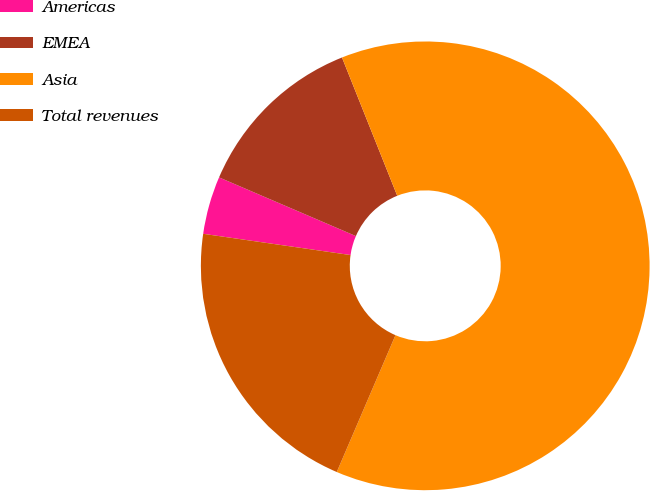Convert chart to OTSL. <chart><loc_0><loc_0><loc_500><loc_500><pie_chart><fcel>Americas<fcel>EMEA<fcel>Asia<fcel>Total revenues<nl><fcel>4.17%<fcel>12.5%<fcel>62.5%<fcel>20.83%<nl></chart> 